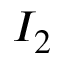<formula> <loc_0><loc_0><loc_500><loc_500>I _ { 2 }</formula> 